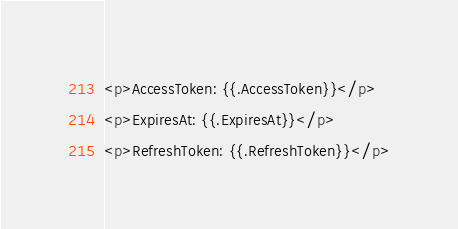Convert code to text. <code><loc_0><loc_0><loc_500><loc_500><_HTML_><p>AccessToken: {{.AccessToken}}</p>
<p>ExpiresAt: {{.ExpiresAt}}</p>
<p>RefreshToken: {{.RefreshToken}}</p></code> 